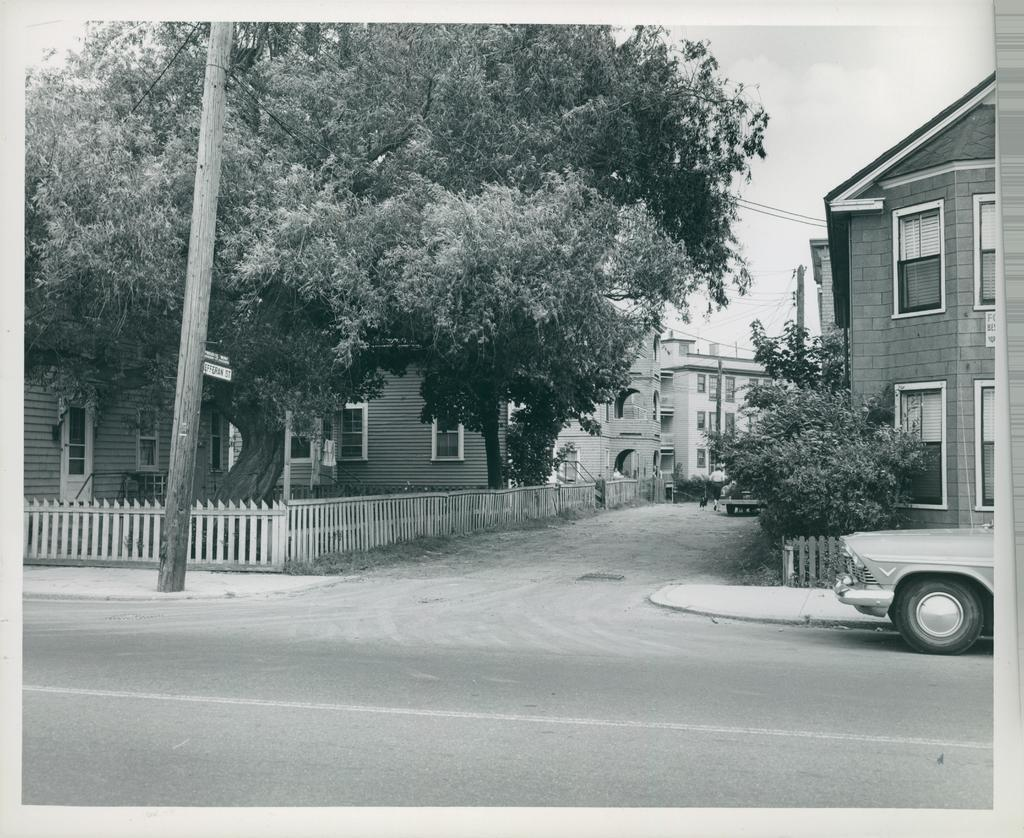What is the color scheme of the image? The image is black and white. What can be seen on the road in the image? There is an empty road and a car on the road in the image. What type of barrier is present in the image? There is a fence in the image. What type of vegetation is visible in the image? There are trees in the image. What type of structures are present in the image? There are buildings in the image. Where are the boats located in the image? There are no boats present in the image. Can you describe the park that is visible in the image? There is no park visible in the image. 